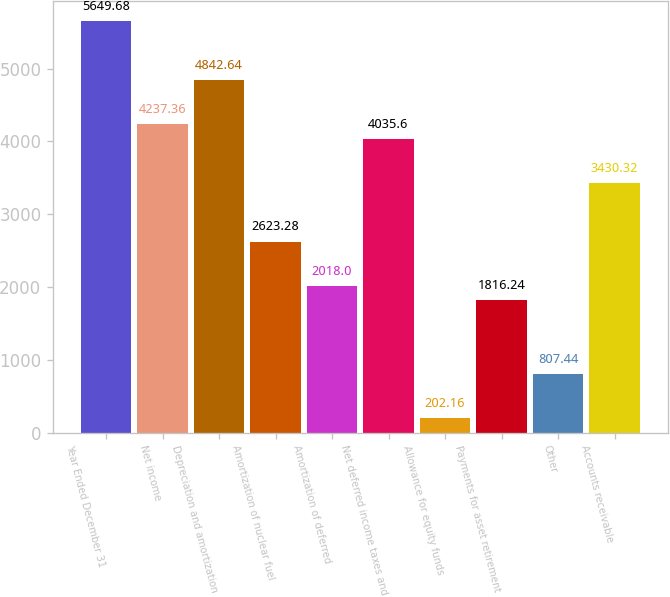Convert chart. <chart><loc_0><loc_0><loc_500><loc_500><bar_chart><fcel>Year Ended December 31<fcel>Net income<fcel>Depreciation and amortization<fcel>Amortization of nuclear fuel<fcel>Amortization of deferred<fcel>Net deferred income taxes and<fcel>Allowance for equity funds<fcel>Payments for asset retirement<fcel>Other<fcel>Accounts receivable<nl><fcel>5649.68<fcel>4237.36<fcel>4842.64<fcel>2623.28<fcel>2018<fcel>4035.6<fcel>202.16<fcel>1816.24<fcel>807.44<fcel>3430.32<nl></chart> 